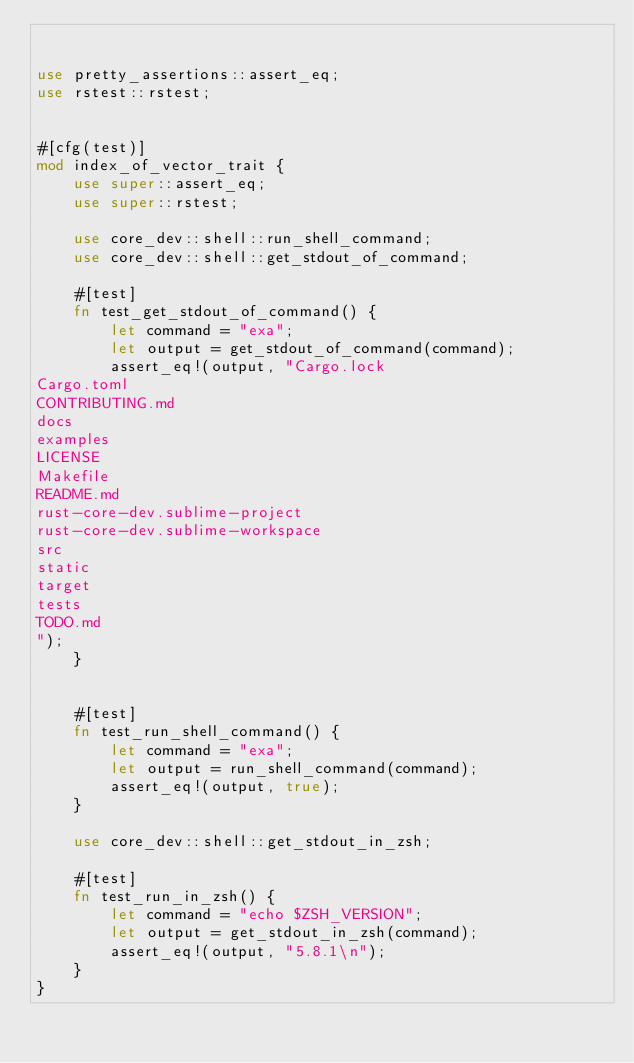<code> <loc_0><loc_0><loc_500><loc_500><_Rust_>

use pretty_assertions::assert_eq;
use rstest::rstest;


#[cfg(test)]
mod index_of_vector_trait {
    use super::assert_eq;
    use super::rstest;

    use core_dev::shell::run_shell_command;
    use core_dev::shell::get_stdout_of_command;

    #[test]
    fn test_get_stdout_of_command() {
        let command = "exa";
        let output = get_stdout_of_command(command);
        assert_eq!(output, "Cargo.lock
Cargo.toml
CONTRIBUTING.md
docs
examples
LICENSE
Makefile
README.md
rust-core-dev.sublime-project
rust-core-dev.sublime-workspace
src
static
target
tests
TODO.md
");
    }


    #[test]
    fn test_run_shell_command() {
        let command = "exa";
        let output = run_shell_command(command);
        assert_eq!(output, true);
    }

    use core_dev::shell::get_stdout_in_zsh;

    #[test]
    fn test_run_in_zsh() {
        let command = "echo $ZSH_VERSION";
        let output = get_stdout_in_zsh(command);
        assert_eq!(output, "5.8.1\n");
    }
}
</code> 